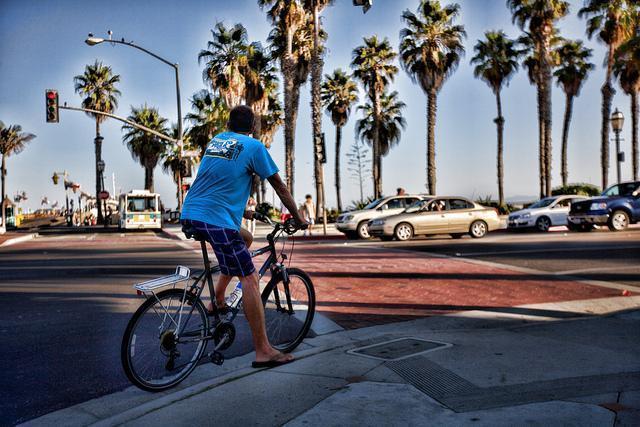What kind of transportation is shown?
Answer the question by selecting the correct answer among the 4 following choices.
Options: Rail, water, air, road. Road. 